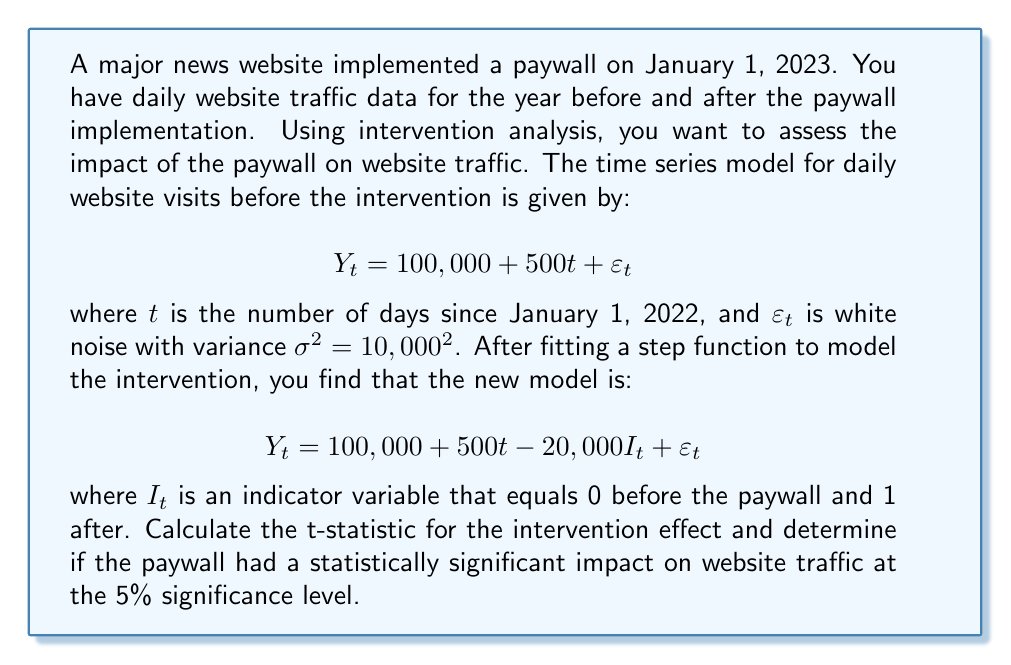Solve this math problem. To solve this problem, we need to follow these steps:

1. Identify the intervention effect:
   The intervention effect is represented by the coefficient of $I_t$, which is -20,000.

2. Calculate the standard error of the intervention effect:
   In intervention analysis, the standard error of the intervention effect is typically estimated from the residual variance of the model. Here, we're given that $\varepsilon_t$ has a variance of $\sigma^2 = 10,000^2$.
   
   The standard error (SE) of the intervention effect is equal to $\sigma$:
   $$ SE = 10,000 $$

3. Calculate the t-statistic:
   The t-statistic is calculated as the ratio of the intervention effect to its standard error:
   
   $$ t = \frac{\text{Intervention Effect}}{SE} = \frac{-20,000}{10,000} = -2 $$

4. Determine the critical value:
   For a two-tailed test at the 5% significance level with a large sample size (we have a year of daily data, so n > 300), we can use the normal distribution critical value of ±1.96.

5. Compare the t-statistic to the critical value:
   The absolute value of our t-statistic (|-2| = 2) is greater than 1.96.

6. Make a conclusion:
   Since |t| > 1.96, we reject the null hypothesis at the 5% significance level. This suggests that the paywall had a statistically significant impact on website traffic.
Answer: The t-statistic for the intervention effect is -2. Since |-2| > 1.96 (the critical value at the 5% significance level), we conclude that the paywall had a statistically significant negative impact on website traffic. 